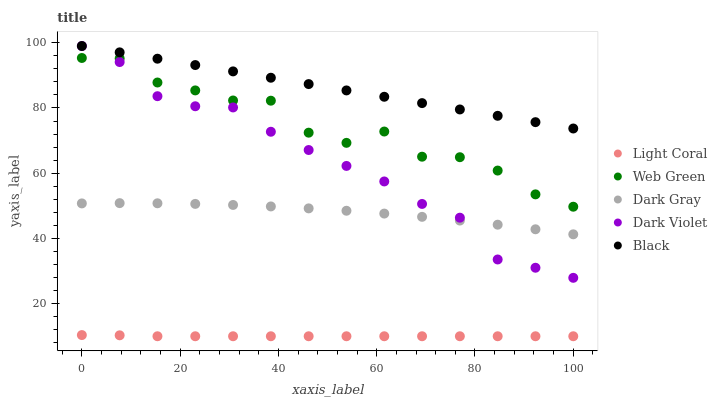Does Light Coral have the minimum area under the curve?
Answer yes or no. Yes. Does Black have the maximum area under the curve?
Answer yes or no. Yes. Does Dark Gray have the minimum area under the curve?
Answer yes or no. No. Does Dark Gray have the maximum area under the curve?
Answer yes or no. No. Is Black the smoothest?
Answer yes or no. Yes. Is Web Green the roughest?
Answer yes or no. Yes. Is Dark Gray the smoothest?
Answer yes or no. No. Is Dark Gray the roughest?
Answer yes or no. No. Does Light Coral have the lowest value?
Answer yes or no. Yes. Does Dark Gray have the lowest value?
Answer yes or no. No. Does Dark Violet have the highest value?
Answer yes or no. Yes. Does Dark Gray have the highest value?
Answer yes or no. No. Is Dark Gray less than Web Green?
Answer yes or no. Yes. Is Dark Violet greater than Light Coral?
Answer yes or no. Yes. Does Black intersect Dark Violet?
Answer yes or no. Yes. Is Black less than Dark Violet?
Answer yes or no. No. Is Black greater than Dark Violet?
Answer yes or no. No. Does Dark Gray intersect Web Green?
Answer yes or no. No. 